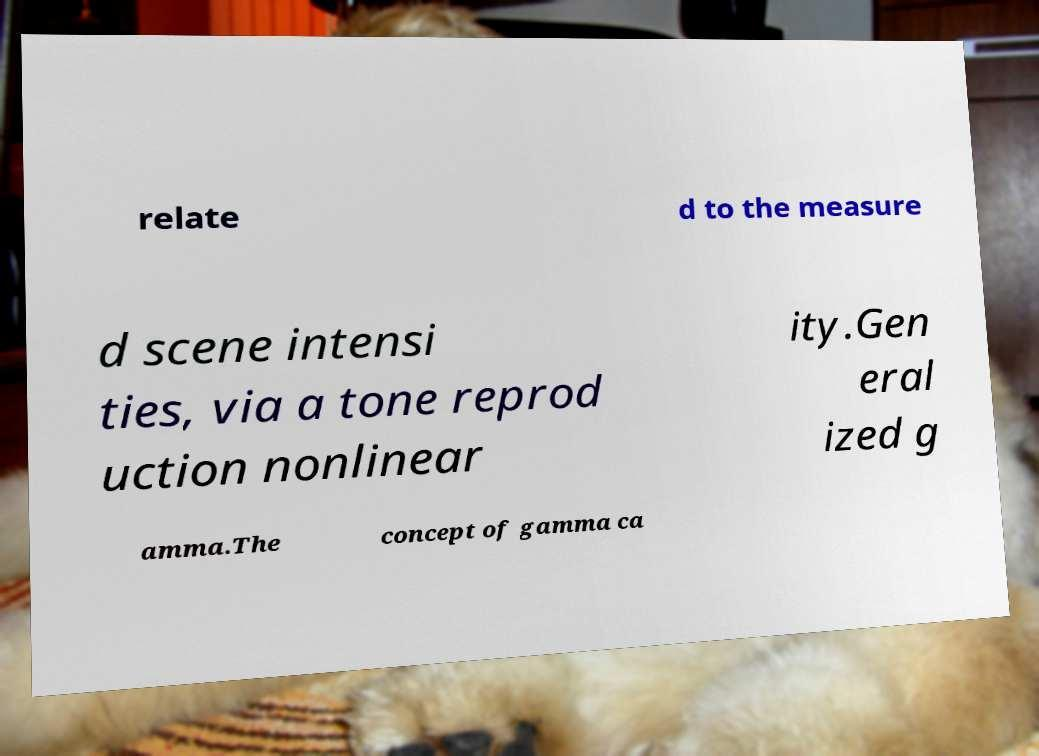Could you assist in decoding the text presented in this image and type it out clearly? relate d to the measure d scene intensi ties, via a tone reprod uction nonlinear ity.Gen eral ized g amma.The concept of gamma ca 